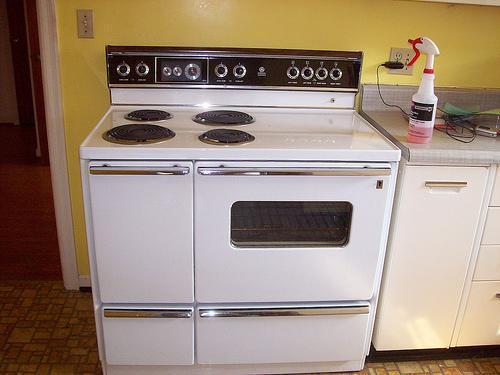How many ovens are there?
Give a very brief answer. 1. 